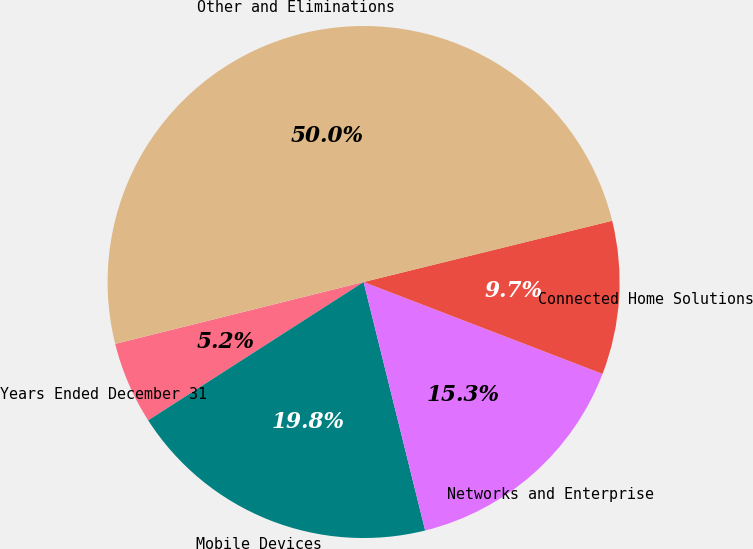<chart> <loc_0><loc_0><loc_500><loc_500><pie_chart><fcel>Years Ended December 31<fcel>Mobile Devices<fcel>Networks and Enterprise<fcel>Connected Home Solutions<fcel>Other and Eliminations<nl><fcel>5.2%<fcel>19.78%<fcel>15.29%<fcel>9.69%<fcel>50.04%<nl></chart> 